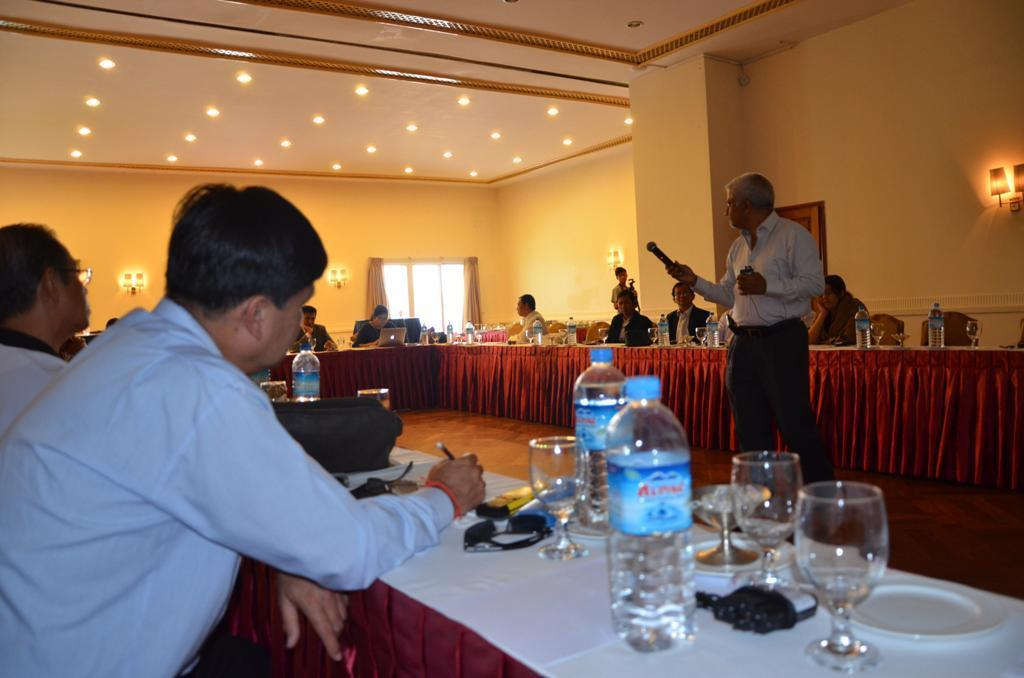What are the people in the image doing? There is a group of people sitting on chairs in the image. What can be seen on the table in the image? There is a water bottle, a glass, and a plate on the table in the image. What is visible in the background of the image? There is a wall visible in the background of the image. What type of soap is being used by the people in the image? There is no soap present in the image; it features a group of people sitting on chairs and items on a table. 